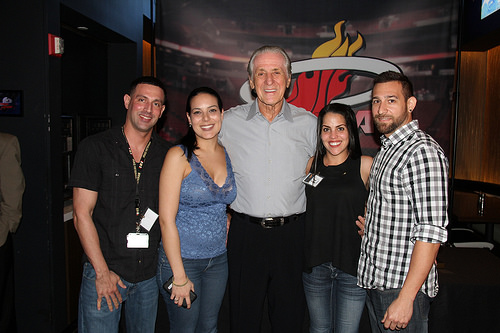<image>
Is there a woman to the left of the man? Yes. From this viewpoint, the woman is positioned to the left side relative to the man. Is the man behind the woman? Yes. From this viewpoint, the man is positioned behind the woman, with the woman partially or fully occluding the man. 